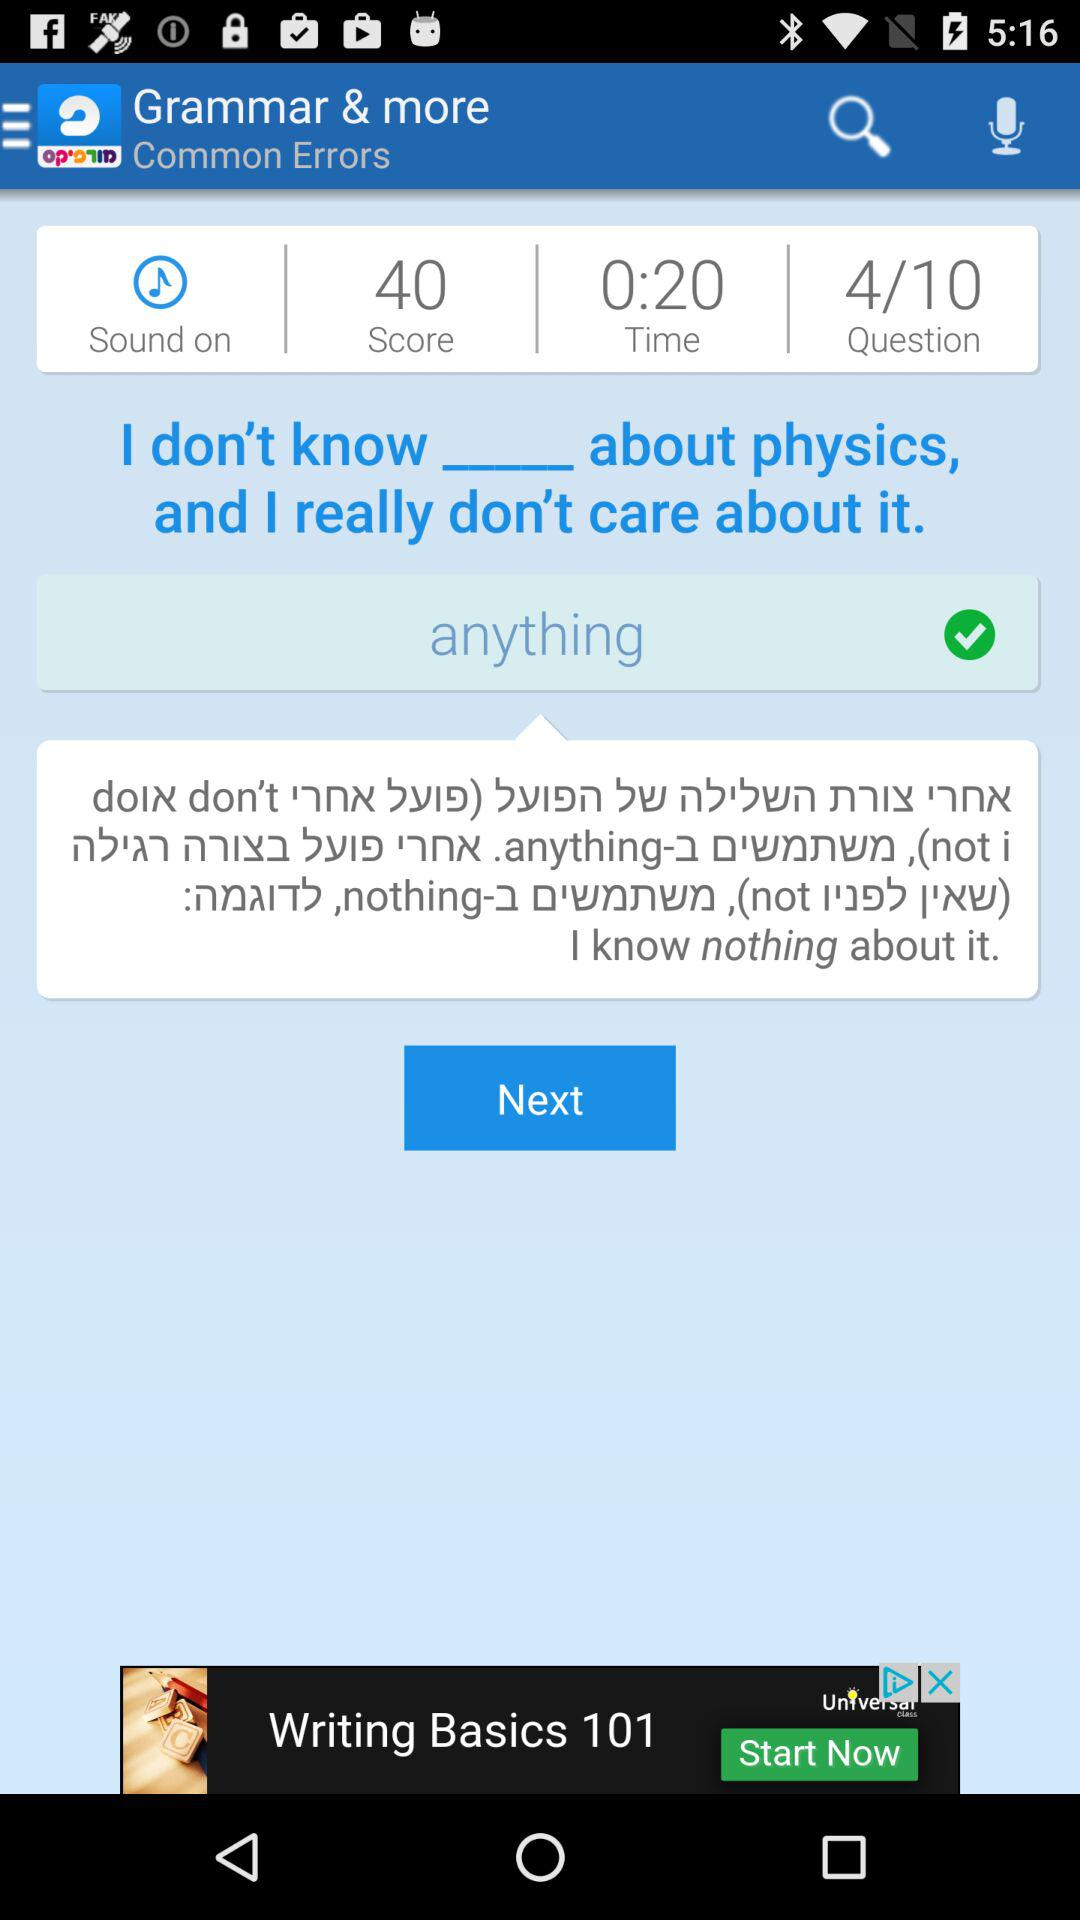What's the status of sound? The status of sound is "on". 